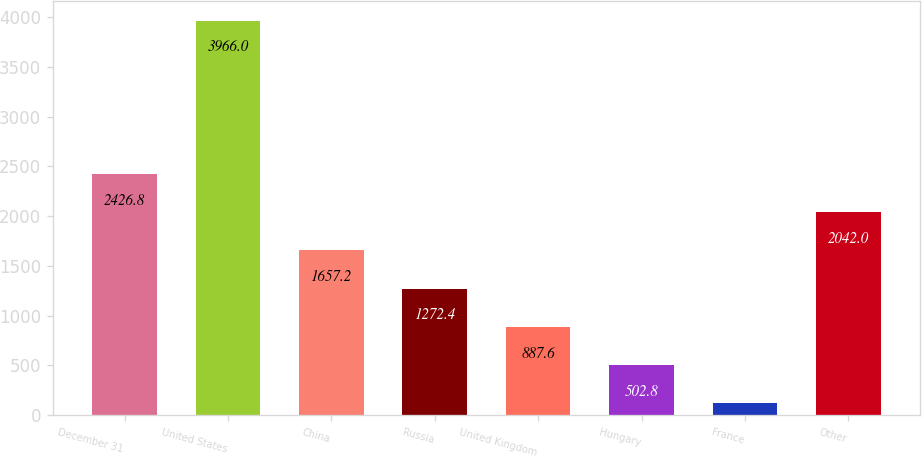Convert chart. <chart><loc_0><loc_0><loc_500><loc_500><bar_chart><fcel>December 31<fcel>United States<fcel>China<fcel>Russia<fcel>United Kingdom<fcel>Hungary<fcel>France<fcel>Other<nl><fcel>2426.8<fcel>3966<fcel>1657.2<fcel>1272.4<fcel>887.6<fcel>502.8<fcel>118<fcel>2042<nl></chart> 